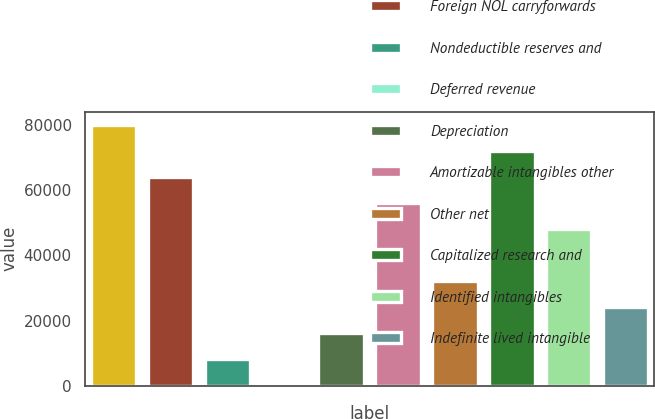Convert chart to OTSL. <chart><loc_0><loc_0><loc_500><loc_500><bar_chart><fcel>NOL carryforwards and tax<fcel>Foreign NOL carryforwards<fcel>Nondeductible reserves and<fcel>Deferred revenue<fcel>Depreciation<fcel>Amortizable intangibles other<fcel>Other net<fcel>Capitalized research and<fcel>Identified intangibles<fcel>Indefinite lived intangible<nl><fcel>80131<fcel>64157.4<fcel>8249.8<fcel>263<fcel>16236.6<fcel>56170.6<fcel>32210.2<fcel>72144.2<fcel>48183.8<fcel>24223.4<nl></chart> 